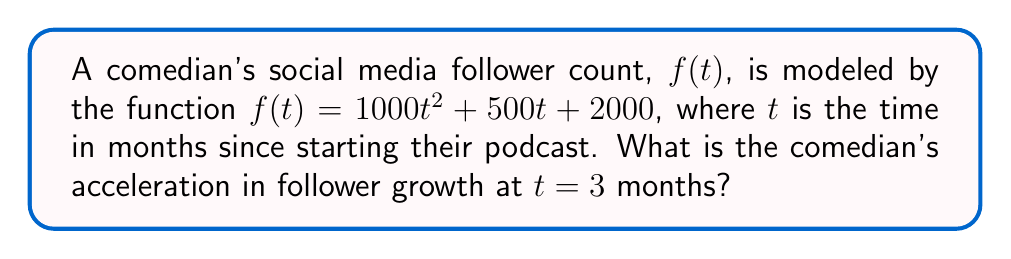Solve this math problem. To find the acceleration of follower growth, we need to calculate the second derivative of the function $f(t)$.

Step 1: Find the first derivative $f'(t)$.
The first derivative represents the rate of change of followers (velocity of growth).
$$f'(t) = \frac{d}{dt}(1000t^2 + 500t + 2000)$$
$$f'(t) = 2000t + 500$$

Step 2: Find the second derivative $f''(t)$.
The second derivative represents the rate of change of the velocity (acceleration of growth).
$$f''(t) = \frac{d}{dt}(2000t + 500)$$
$$f''(t) = 2000$$

Step 3: Evaluate $f''(t)$ at $t = 3$.
Since $f''(t)$ is a constant function, its value is the same for all $t$, including $t = 3$.

$$f''(3) = 2000$$

Therefore, the comedian's acceleration in follower growth at $t = 3$ months is 2000 followers per month squared.
Answer: 2000 followers/month² 